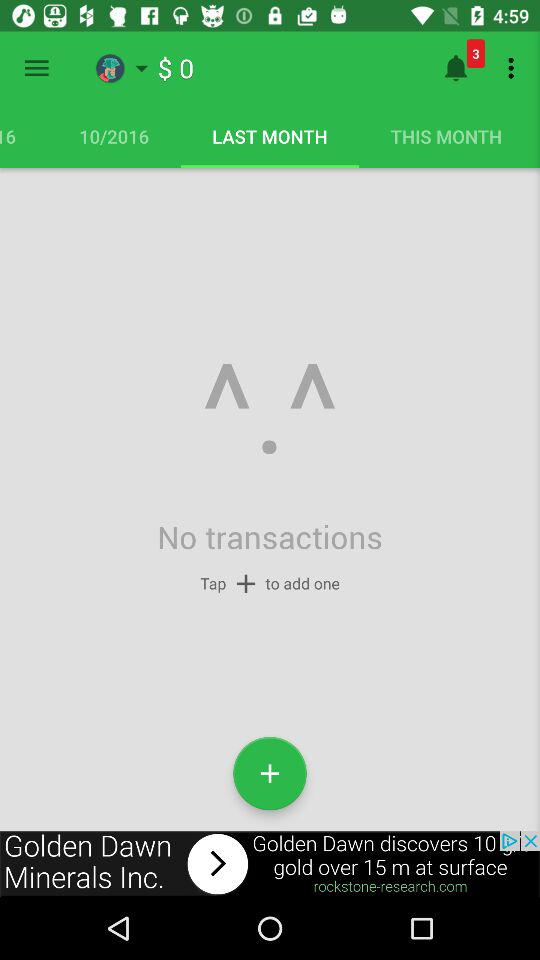How many notifications are pending? There are 3 pending notifications. 